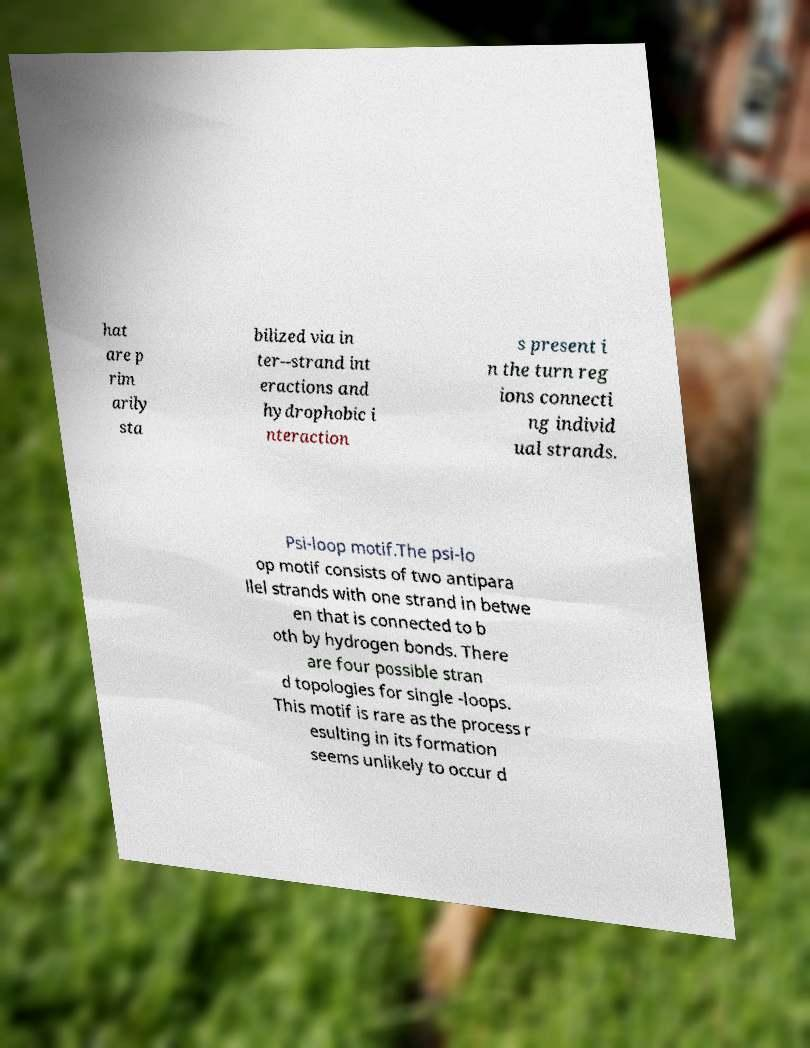For documentation purposes, I need the text within this image transcribed. Could you provide that? hat are p rim arily sta bilized via in ter--strand int eractions and hydrophobic i nteraction s present i n the turn reg ions connecti ng individ ual strands. Psi-loop motif.The psi-lo op motif consists of two antipara llel strands with one strand in betwe en that is connected to b oth by hydrogen bonds. There are four possible stran d topologies for single -loops. This motif is rare as the process r esulting in its formation seems unlikely to occur d 